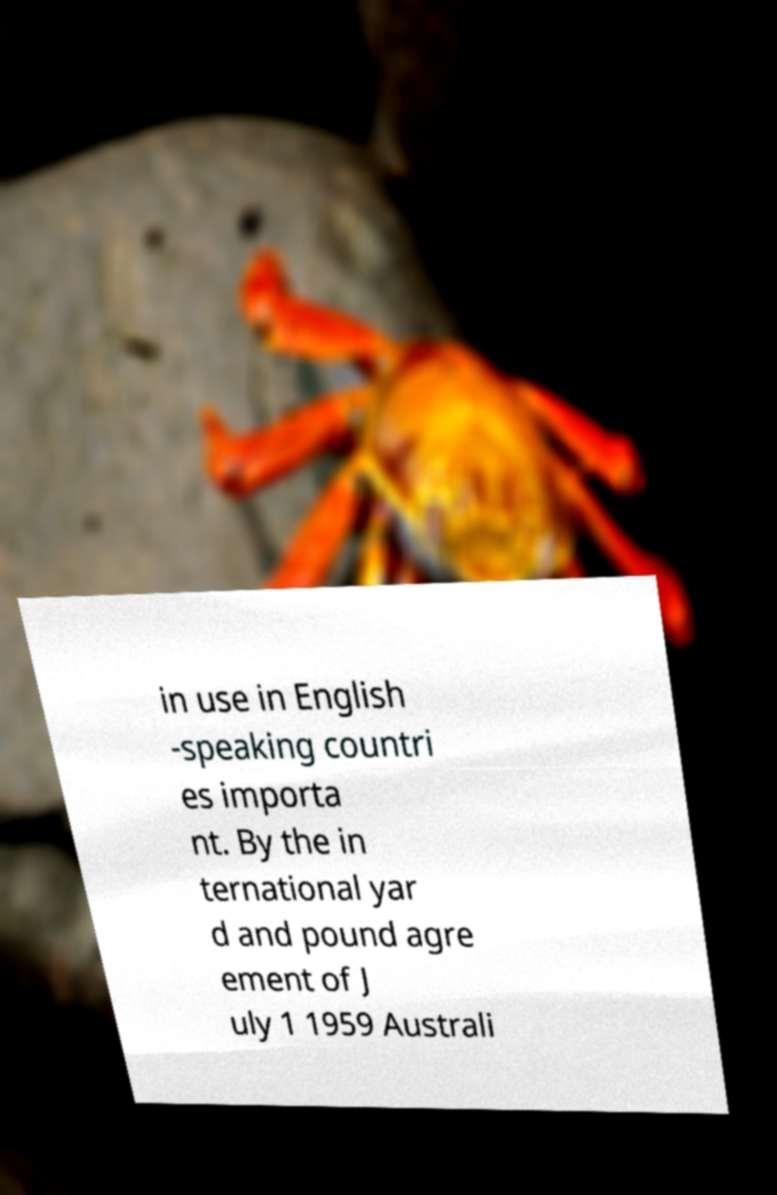For documentation purposes, I need the text within this image transcribed. Could you provide that? in use in English -speaking countri es importa nt. By the in ternational yar d and pound agre ement of J uly 1 1959 Australi 